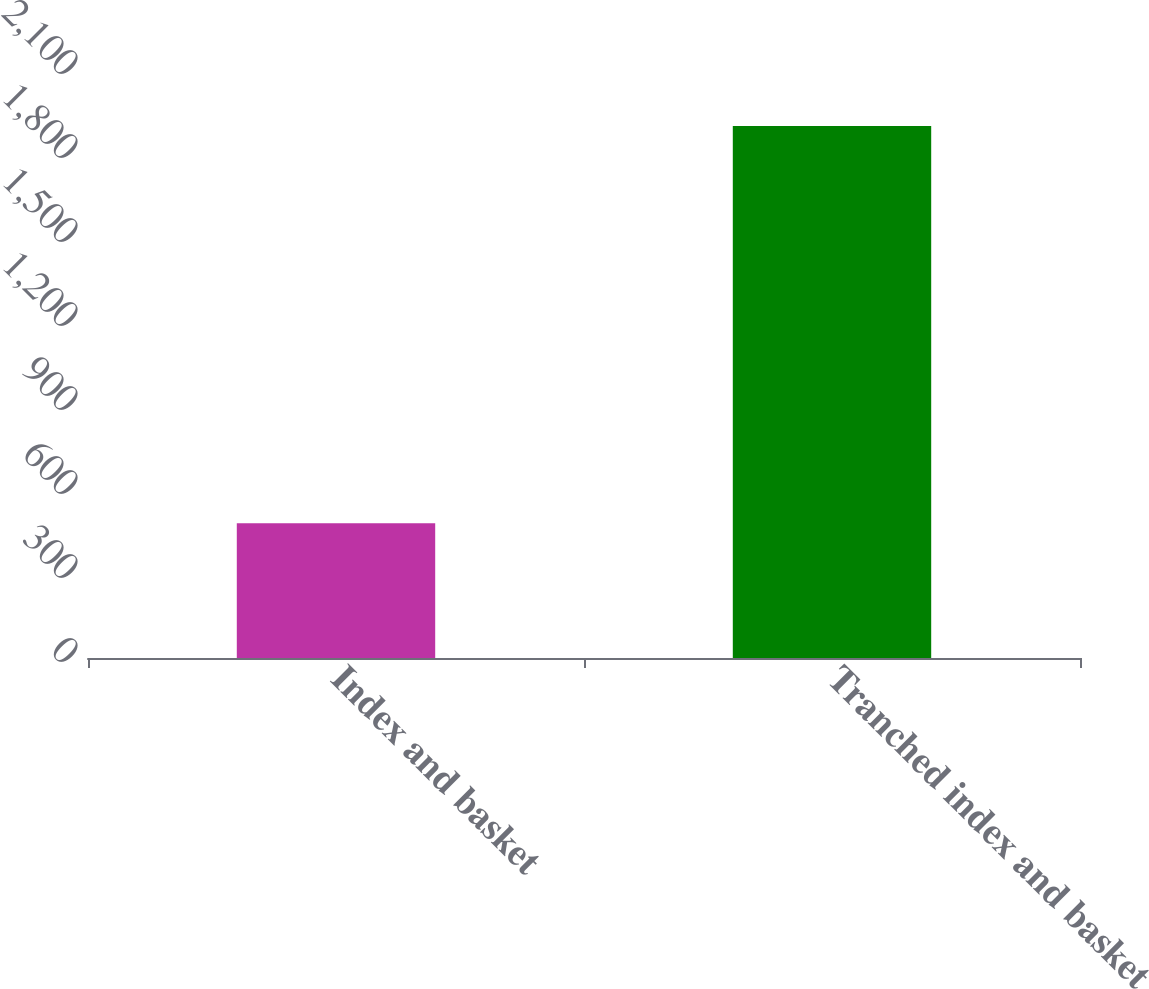<chart> <loc_0><loc_0><loc_500><loc_500><bar_chart><fcel>Index and basket<fcel>Tranched index and basket<nl><fcel>481<fcel>1900<nl></chart> 